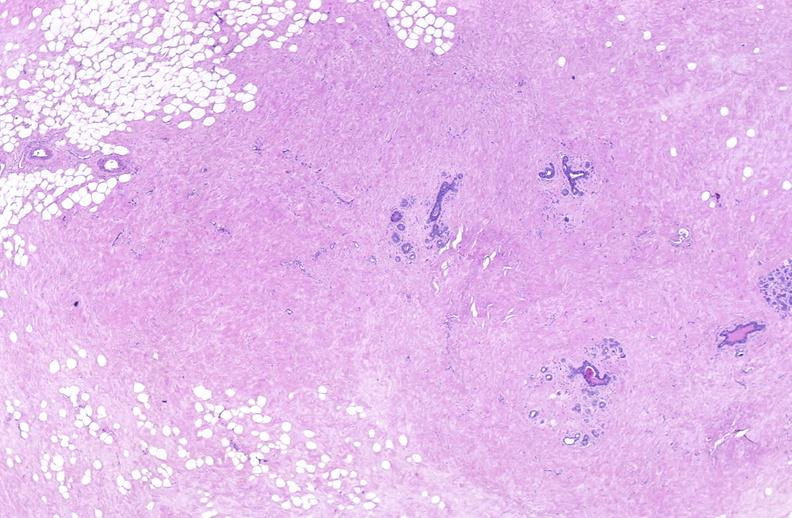what does this image show?
Answer the question using a single word or phrase. Breast 